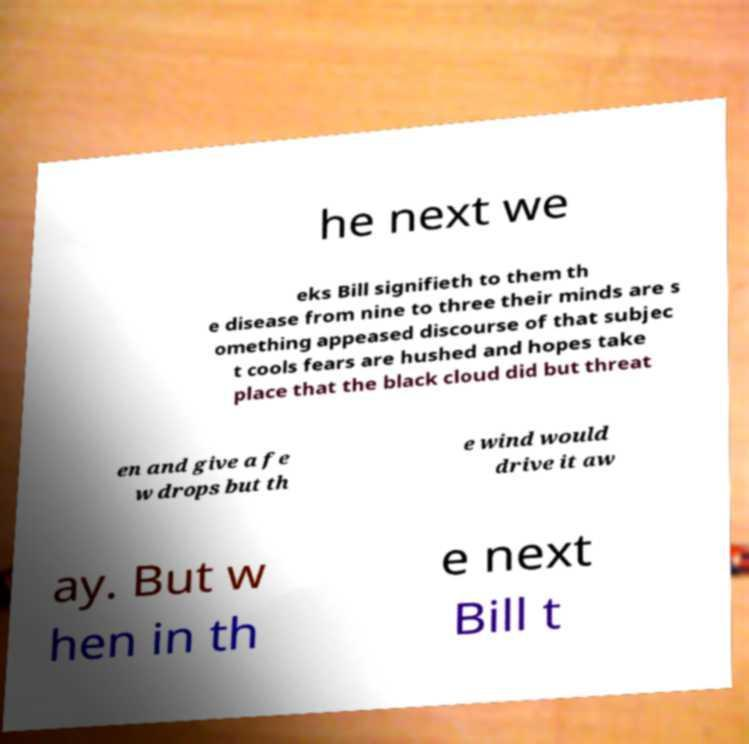Please read and relay the text visible in this image. What does it say? he next we eks Bill signifieth to them th e disease from nine to three their minds are s omething appeased discourse of that subjec t cools fears are hushed and hopes take place that the black cloud did but threat en and give a fe w drops but th e wind would drive it aw ay. But w hen in th e next Bill t 